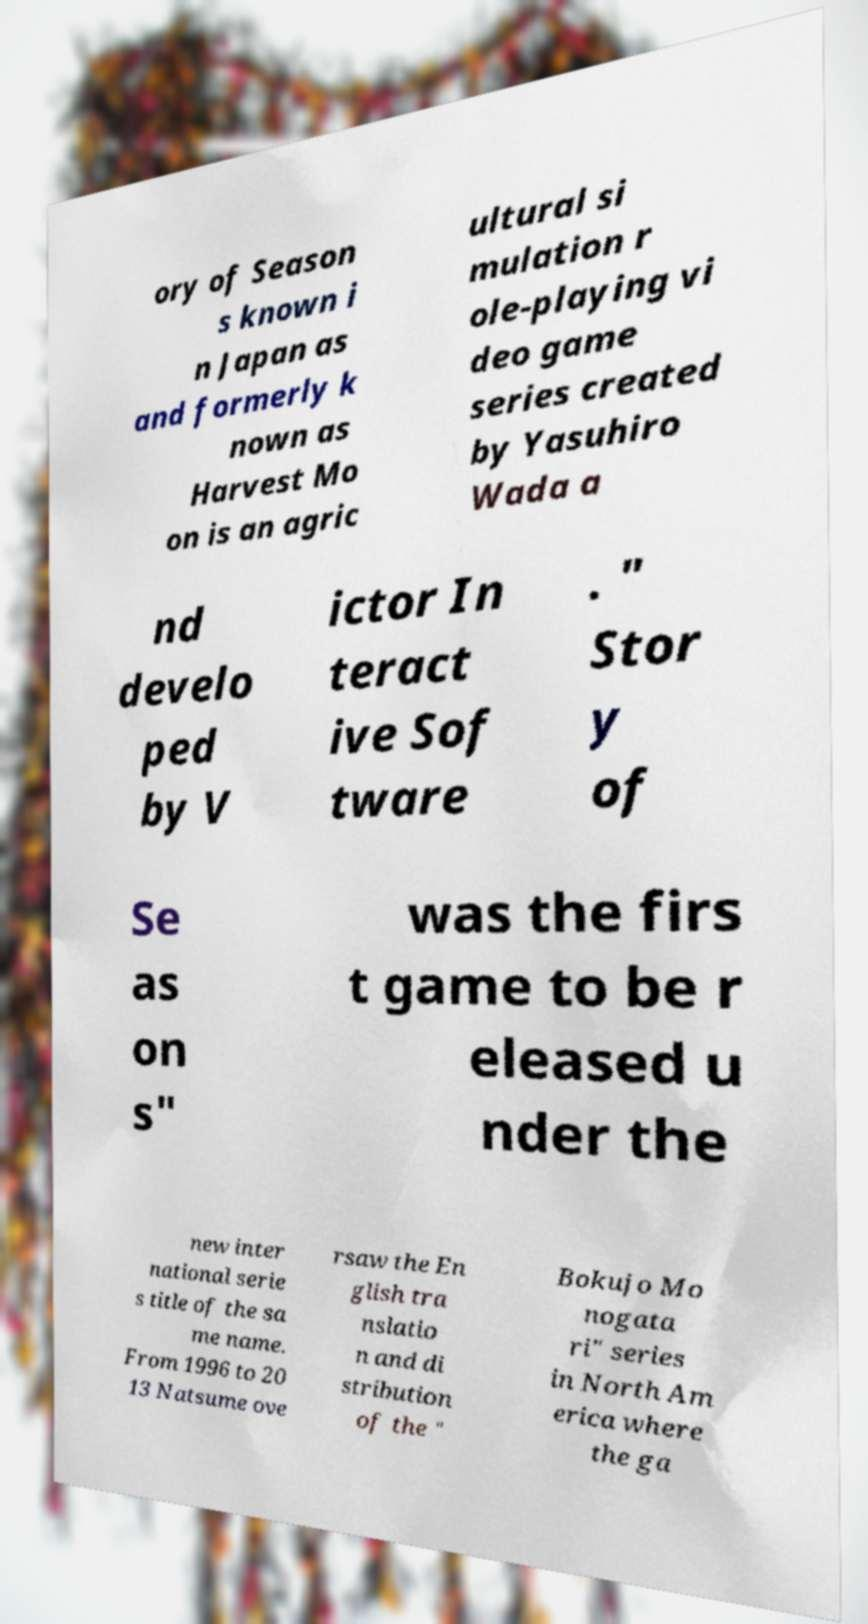Please read and relay the text visible in this image. What does it say? ory of Season s known i n Japan as and formerly k nown as Harvest Mo on is an agric ultural si mulation r ole-playing vi deo game series created by Yasuhiro Wada a nd develo ped by V ictor In teract ive Sof tware . " Stor y of Se as on s" was the firs t game to be r eleased u nder the new inter national serie s title of the sa me name. From 1996 to 20 13 Natsume ove rsaw the En glish tra nslatio n and di stribution of the " Bokujo Mo nogata ri" series in North Am erica where the ga 